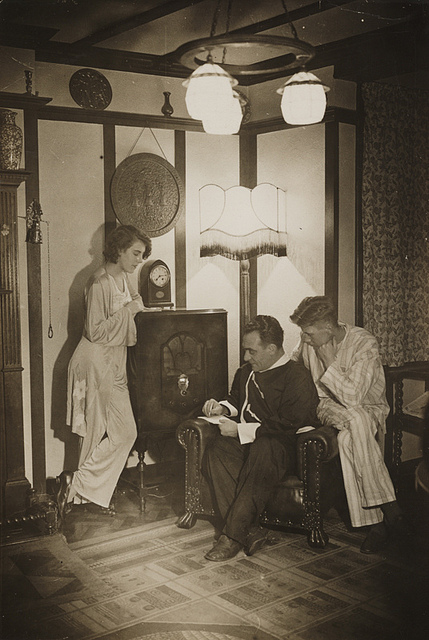<image>What instrument in the second from the left holding? I am not sure what instrument is being held in the second from the left. It could be a pen, a pencil, a calculator, a book, or nothing at all. What instrument in the second from the left holding? I don't know what instrument is the second from the left holding. 